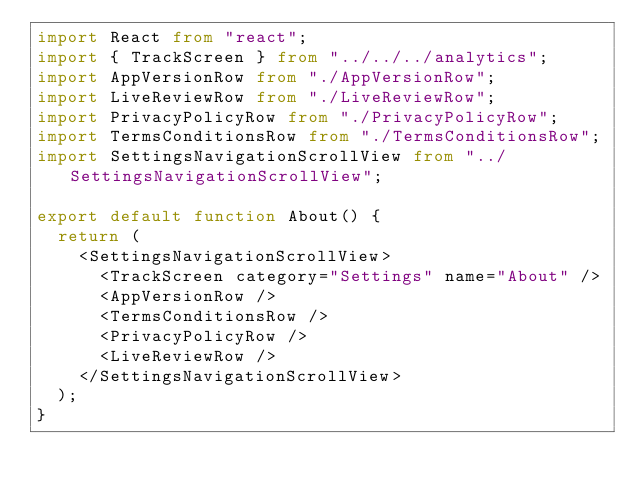<code> <loc_0><loc_0><loc_500><loc_500><_TypeScript_>import React from "react";
import { TrackScreen } from "../../../analytics";
import AppVersionRow from "./AppVersionRow";
import LiveReviewRow from "./LiveReviewRow";
import PrivacyPolicyRow from "./PrivacyPolicyRow";
import TermsConditionsRow from "./TermsConditionsRow";
import SettingsNavigationScrollView from "../SettingsNavigationScrollView";

export default function About() {
  return (
    <SettingsNavigationScrollView>
      <TrackScreen category="Settings" name="About" />
      <AppVersionRow />
      <TermsConditionsRow />
      <PrivacyPolicyRow />
      <LiveReviewRow />
    </SettingsNavigationScrollView>
  );
}
</code> 